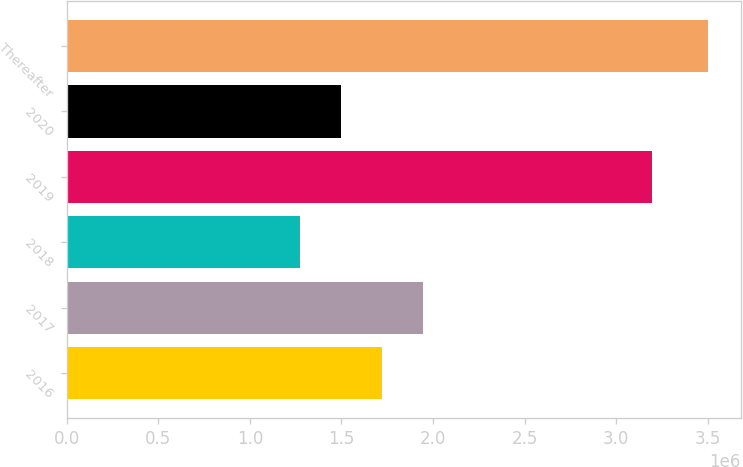Convert chart to OTSL. <chart><loc_0><loc_0><loc_500><loc_500><bar_chart><fcel>2016<fcel>2017<fcel>2018<fcel>2019<fcel>2020<fcel>Thereafter<nl><fcel>1.72324e+06<fcel>1.94647e+06<fcel>1.27245e+06<fcel>3.19696e+06<fcel>1.5e+06<fcel>3.50482e+06<nl></chart> 